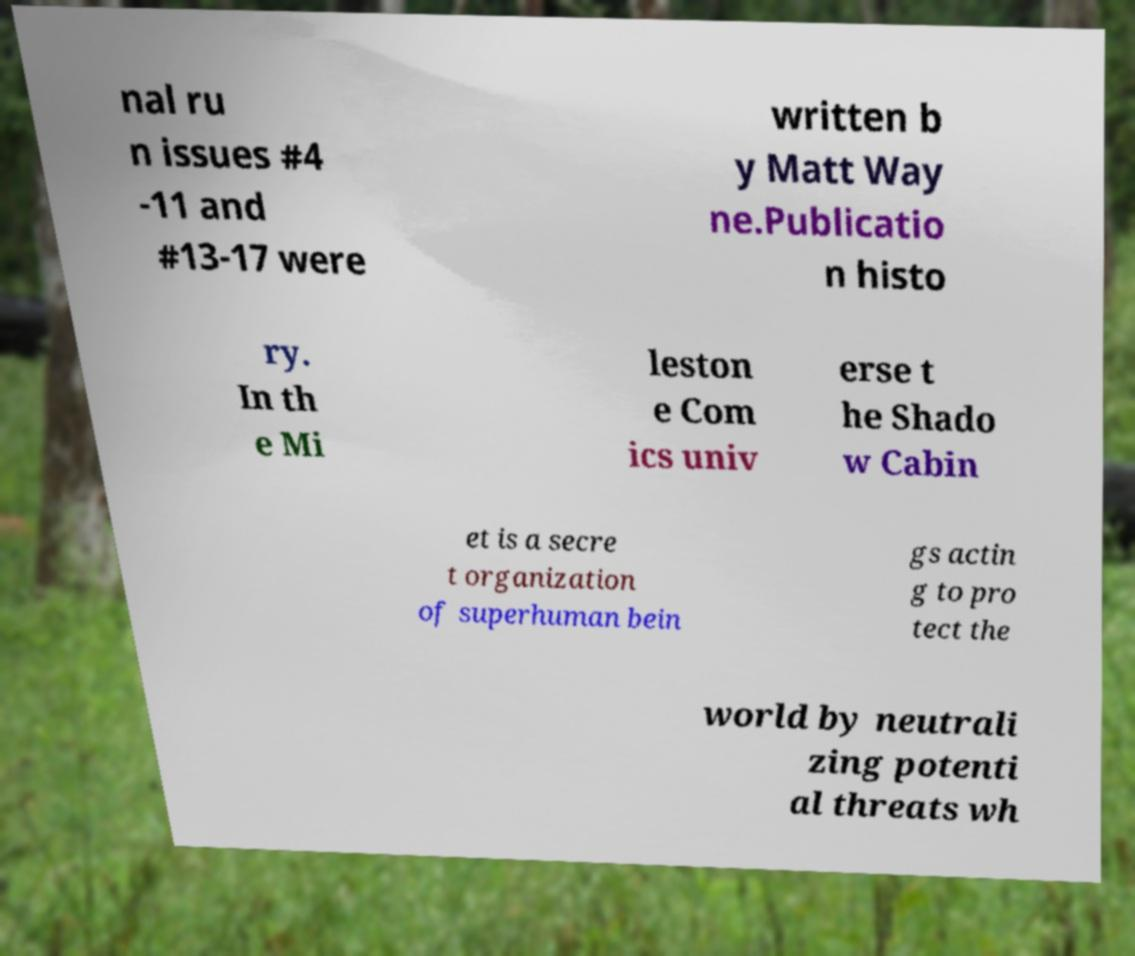I need the written content from this picture converted into text. Can you do that? nal ru n issues #4 -11 and #13-17 were written b y Matt Way ne.Publicatio n histo ry. In th e Mi leston e Com ics univ erse t he Shado w Cabin et is a secre t organization of superhuman bein gs actin g to pro tect the world by neutrali zing potenti al threats wh 